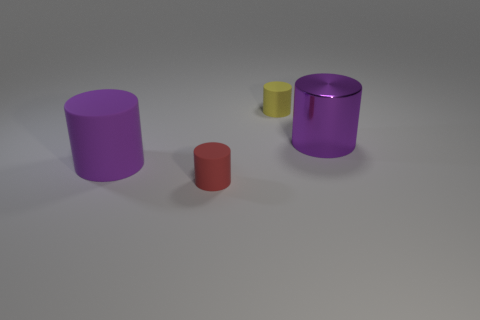Is there any discernible light source in the image? The light source isn't directly visible, but judging by the shadows and highlights, it seems to be coming from the top left direction, casting soft shadows to the right of the objects. What can you infer about the surface the cylinders are resting on? The surface appears to be flat and even, with a subtle texture that reflects some light, indicative of a matte finish which might suggest a typical indoor setting. 